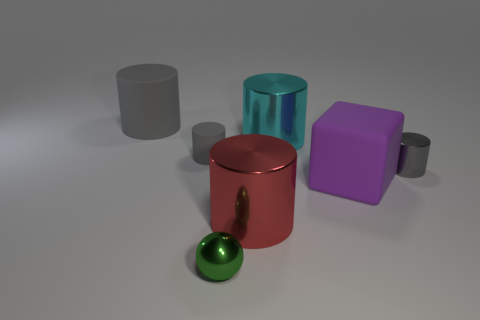There is a small shiny object that is left of the big shiny thing that is in front of the gray object that is on the right side of the tiny sphere; what shape is it?
Offer a very short reply. Sphere. There is a cylinder that is behind the small rubber cylinder and to the left of the small green thing; what material is it?
Provide a succinct answer. Rubber. Does the object right of the rubber block have the same size as the tiny green sphere?
Your answer should be very brief. Yes. Is there any other thing that is the same size as the purple rubber object?
Keep it short and to the point. Yes. Are there more small spheres to the left of the small green object than big shiny cylinders that are in front of the small gray metallic object?
Make the answer very short. No. What color is the big thing behind the shiny cylinder that is behind the gray thing that is to the right of the green ball?
Offer a terse response. Gray. Do the small object left of the shiny ball and the tiny metal ball have the same color?
Keep it short and to the point. No. What number of other objects are there of the same color as the large matte cylinder?
Offer a very short reply. 2. What number of things are either big gray metal cylinders or purple objects?
Provide a short and direct response. 1. How many objects are gray objects or things that are in front of the cube?
Keep it short and to the point. 5. 